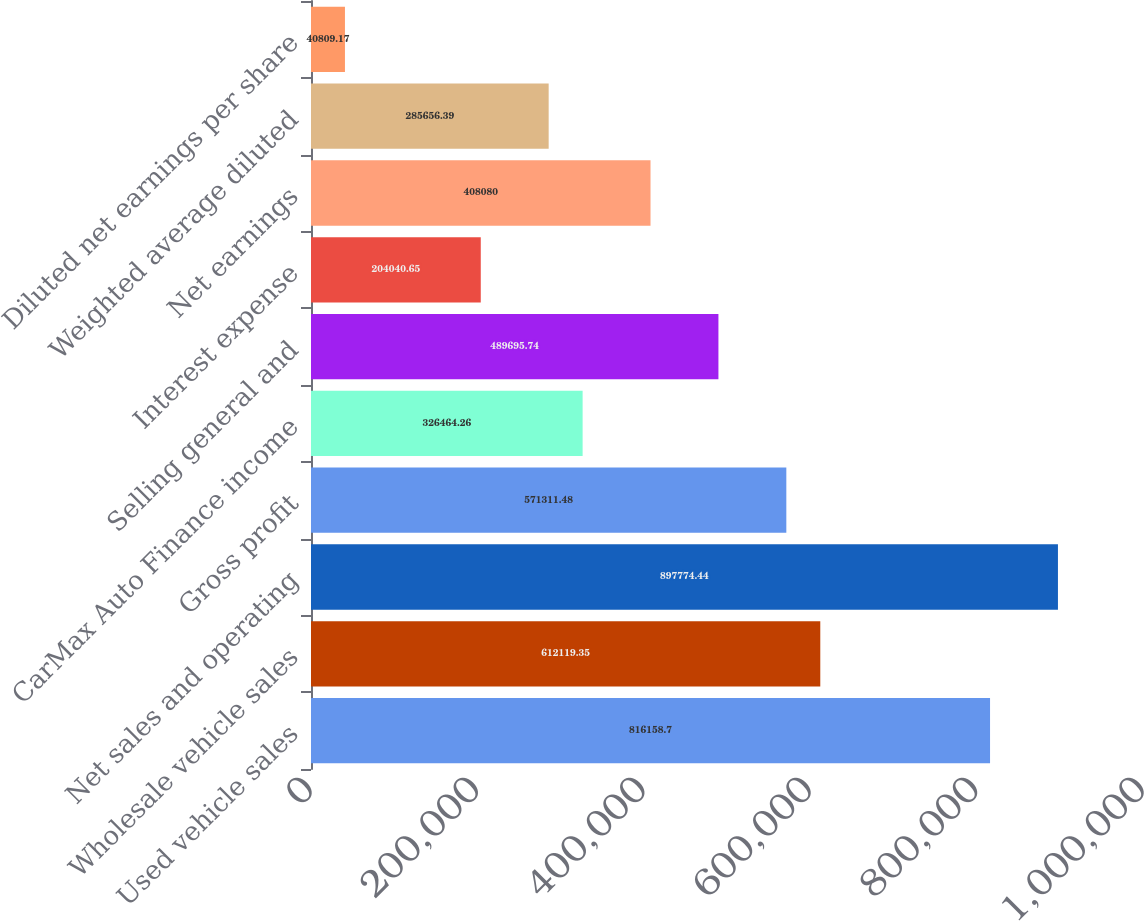Convert chart. <chart><loc_0><loc_0><loc_500><loc_500><bar_chart><fcel>Used vehicle sales<fcel>Wholesale vehicle sales<fcel>Net sales and operating<fcel>Gross profit<fcel>CarMax Auto Finance income<fcel>Selling general and<fcel>Interest expense<fcel>Net earnings<fcel>Weighted average diluted<fcel>Diluted net earnings per share<nl><fcel>816159<fcel>612119<fcel>897774<fcel>571311<fcel>326464<fcel>489696<fcel>204041<fcel>408080<fcel>285656<fcel>40809.2<nl></chart> 